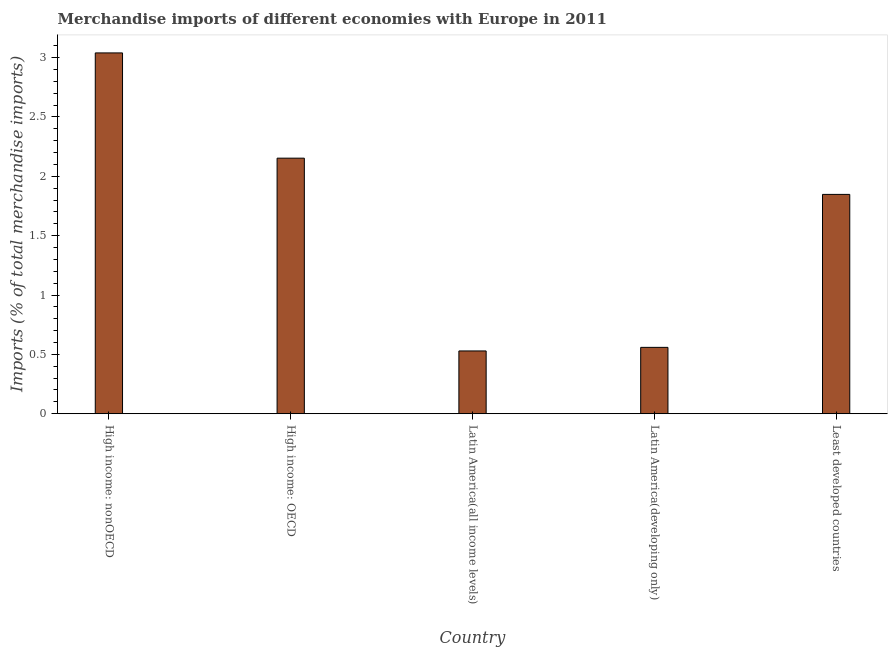Does the graph contain grids?
Provide a succinct answer. No. What is the title of the graph?
Offer a very short reply. Merchandise imports of different economies with Europe in 2011. What is the label or title of the X-axis?
Ensure brevity in your answer.  Country. What is the label or title of the Y-axis?
Keep it short and to the point. Imports (% of total merchandise imports). What is the merchandise imports in Latin America(developing only)?
Your answer should be compact. 0.56. Across all countries, what is the maximum merchandise imports?
Provide a short and direct response. 3.04. Across all countries, what is the minimum merchandise imports?
Keep it short and to the point. 0.53. In which country was the merchandise imports maximum?
Offer a terse response. High income: nonOECD. In which country was the merchandise imports minimum?
Your answer should be compact. Latin America(all income levels). What is the sum of the merchandise imports?
Keep it short and to the point. 8.13. What is the difference between the merchandise imports in High income: nonOECD and Latin America(all income levels)?
Provide a succinct answer. 2.51. What is the average merchandise imports per country?
Your response must be concise. 1.63. What is the median merchandise imports?
Offer a terse response. 1.85. In how many countries, is the merchandise imports greater than 2.5 %?
Ensure brevity in your answer.  1. What is the ratio of the merchandise imports in High income: nonOECD to that in Latin America(developing only)?
Provide a short and direct response. 5.44. Is the merchandise imports in Latin America(all income levels) less than that in Latin America(developing only)?
Ensure brevity in your answer.  Yes. Is the difference between the merchandise imports in Latin America(all income levels) and Least developed countries greater than the difference between any two countries?
Make the answer very short. No. What is the difference between the highest and the second highest merchandise imports?
Make the answer very short. 0.89. What is the difference between the highest and the lowest merchandise imports?
Give a very brief answer. 2.51. Are all the bars in the graph horizontal?
Your response must be concise. No. What is the Imports (% of total merchandise imports) in High income: nonOECD?
Provide a short and direct response. 3.04. What is the Imports (% of total merchandise imports) in High income: OECD?
Offer a terse response. 2.15. What is the Imports (% of total merchandise imports) in Latin America(all income levels)?
Provide a short and direct response. 0.53. What is the Imports (% of total merchandise imports) in Latin America(developing only)?
Provide a short and direct response. 0.56. What is the Imports (% of total merchandise imports) of Least developed countries?
Provide a short and direct response. 1.85. What is the difference between the Imports (% of total merchandise imports) in High income: nonOECD and High income: OECD?
Provide a short and direct response. 0.89. What is the difference between the Imports (% of total merchandise imports) in High income: nonOECD and Latin America(all income levels)?
Provide a short and direct response. 2.51. What is the difference between the Imports (% of total merchandise imports) in High income: nonOECD and Latin America(developing only)?
Give a very brief answer. 2.48. What is the difference between the Imports (% of total merchandise imports) in High income: nonOECD and Least developed countries?
Make the answer very short. 1.19. What is the difference between the Imports (% of total merchandise imports) in High income: OECD and Latin America(all income levels)?
Give a very brief answer. 1.62. What is the difference between the Imports (% of total merchandise imports) in High income: OECD and Latin America(developing only)?
Give a very brief answer. 1.59. What is the difference between the Imports (% of total merchandise imports) in High income: OECD and Least developed countries?
Your response must be concise. 0.31. What is the difference between the Imports (% of total merchandise imports) in Latin America(all income levels) and Latin America(developing only)?
Make the answer very short. -0.03. What is the difference between the Imports (% of total merchandise imports) in Latin America(all income levels) and Least developed countries?
Provide a succinct answer. -1.32. What is the difference between the Imports (% of total merchandise imports) in Latin America(developing only) and Least developed countries?
Give a very brief answer. -1.29. What is the ratio of the Imports (% of total merchandise imports) in High income: nonOECD to that in High income: OECD?
Offer a very short reply. 1.41. What is the ratio of the Imports (% of total merchandise imports) in High income: nonOECD to that in Latin America(all income levels)?
Give a very brief answer. 5.75. What is the ratio of the Imports (% of total merchandise imports) in High income: nonOECD to that in Latin America(developing only)?
Your answer should be very brief. 5.44. What is the ratio of the Imports (% of total merchandise imports) in High income: nonOECD to that in Least developed countries?
Give a very brief answer. 1.65. What is the ratio of the Imports (% of total merchandise imports) in High income: OECD to that in Latin America(all income levels)?
Provide a succinct answer. 4.07. What is the ratio of the Imports (% of total merchandise imports) in High income: OECD to that in Latin America(developing only)?
Offer a very short reply. 3.85. What is the ratio of the Imports (% of total merchandise imports) in High income: OECD to that in Least developed countries?
Your answer should be very brief. 1.17. What is the ratio of the Imports (% of total merchandise imports) in Latin America(all income levels) to that in Latin America(developing only)?
Your answer should be compact. 0.95. What is the ratio of the Imports (% of total merchandise imports) in Latin America(all income levels) to that in Least developed countries?
Ensure brevity in your answer.  0.29. What is the ratio of the Imports (% of total merchandise imports) in Latin America(developing only) to that in Least developed countries?
Offer a terse response. 0.3. 